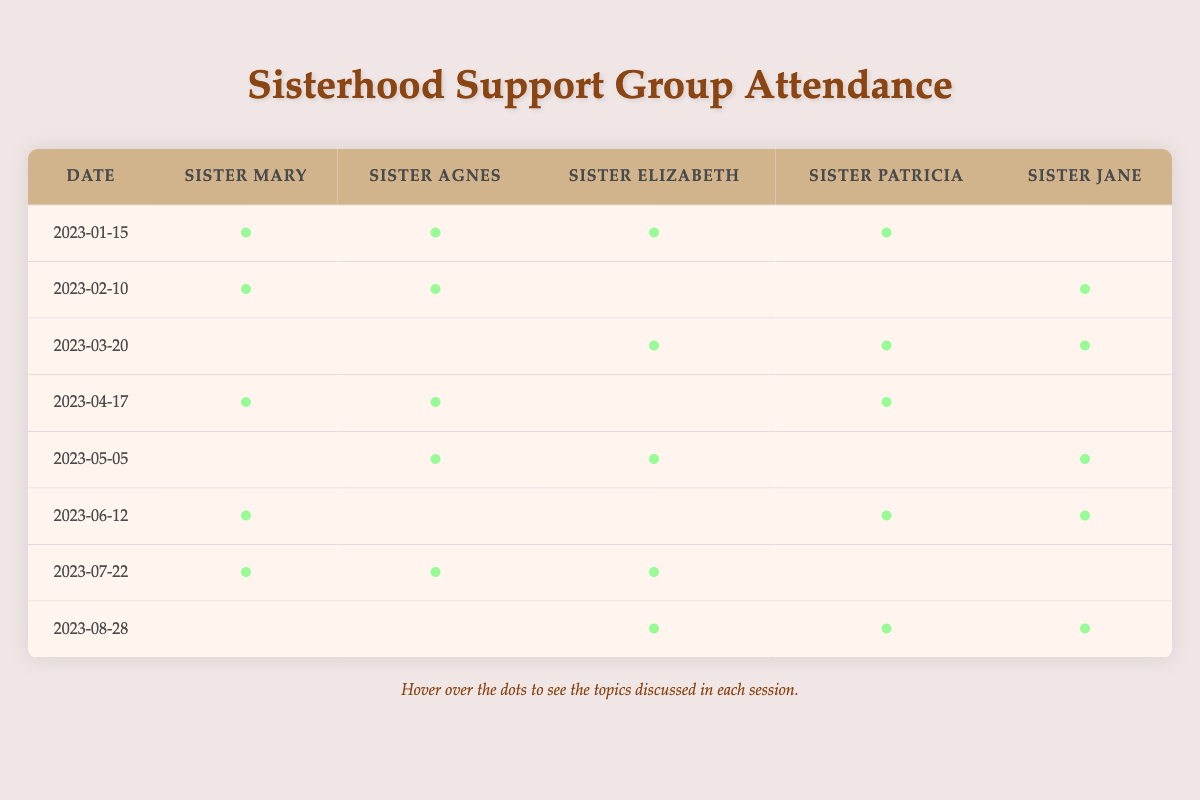What was the date of the meeting where Sister Patricia discussed "Art Therapy"? From the table, we can look for the row where Sister Patricia is marked present with the topic "Art Therapy." This is found in the meeting dated "2023-06-12."
Answer: 2023-06-12 How many times did Sister Mary attend meetings discussing "Self-Care"? By looking at the table, we see Sister Mary attended the meeting on "2023-04-17," where "Self-Care" was discussed. This is her only attendance for that specific topic.
Answer: 1 Did Sister Elizabeth discuss "Sisterhood Bonds" during any meeting? Checking the table, we find "Sisterhood Bonds" mentioned under Sister Elizabeth in the meeting dated "2023-07-22." Therefore, the statement is true.
Answer: Yes Which topic did Sister Jane discuss the most number of times? We can check Sister Jane's attendance in the table. She discussed topics on the following dates: "2023-02-10," "2023-03-20," "2023-06-12," and "2023-08-28," covering four different topics in total. However, "Public Speaking Skills" is discussed more than once, making it the most frequent.
Answer: 4 times Which meeting had the highest number of different topics discussed by the sisters? Analyzing the attendance, each meeting typically has a unique set of topics. The meeting on "2023-01-15" had four distinct topics: "Spiritual Growth," "Community Service," "Mental Health," and "Leadership Skills." Each subsequent meeting discussed different topics but did not exceed this count.
Answer: 4 topics How many topics were discussed in total during the meetings? We count the unique topics from each meeting. The topics include: "Spiritual Growth," "Community Service," "Mental Health," "Leadership Skills," "Scripture Study," "Prayer Techniques," "Conflict Resolution," "Wellness Practices," "Building Community," "Nurturing Relationships," "Self-Care," "Counseling Skills," "Faith-Based Discussions," "Volunteer Opportunities," "Personal Development," "Elderly Care Advocacy," "Forgiveness Practices," "Art Therapy," "Public Speaking Skills," "Coping Mechanisms," "Faith in Action," "Sisterhood Bonds," "Inspirational Stories," "Stress Management," and "Life Balance." Counting these gives a total of 25 distinct topics.
Answer: 25 topics Which sister attended every meeting in the first half of the year? Reviewing the attendance records from January through June, Sister Mary attended meetings on "2023-01-15," "2023-02-10," "2023-04-17," and "2023-06-12." She did not attend the meeting on "2023-03-20" or "2023-05-05," so she did not attend every meeting. Upon checking, it appears no sister attended all these meetings consistently.
Answer: No sister How many sisters attended the meeting on "2023-05-05"? The attendance at that meeting includes Sister Elizabeth, Sister Jane, and Sister Agnes, totaling three sisters.
Answer: 3 sisters 